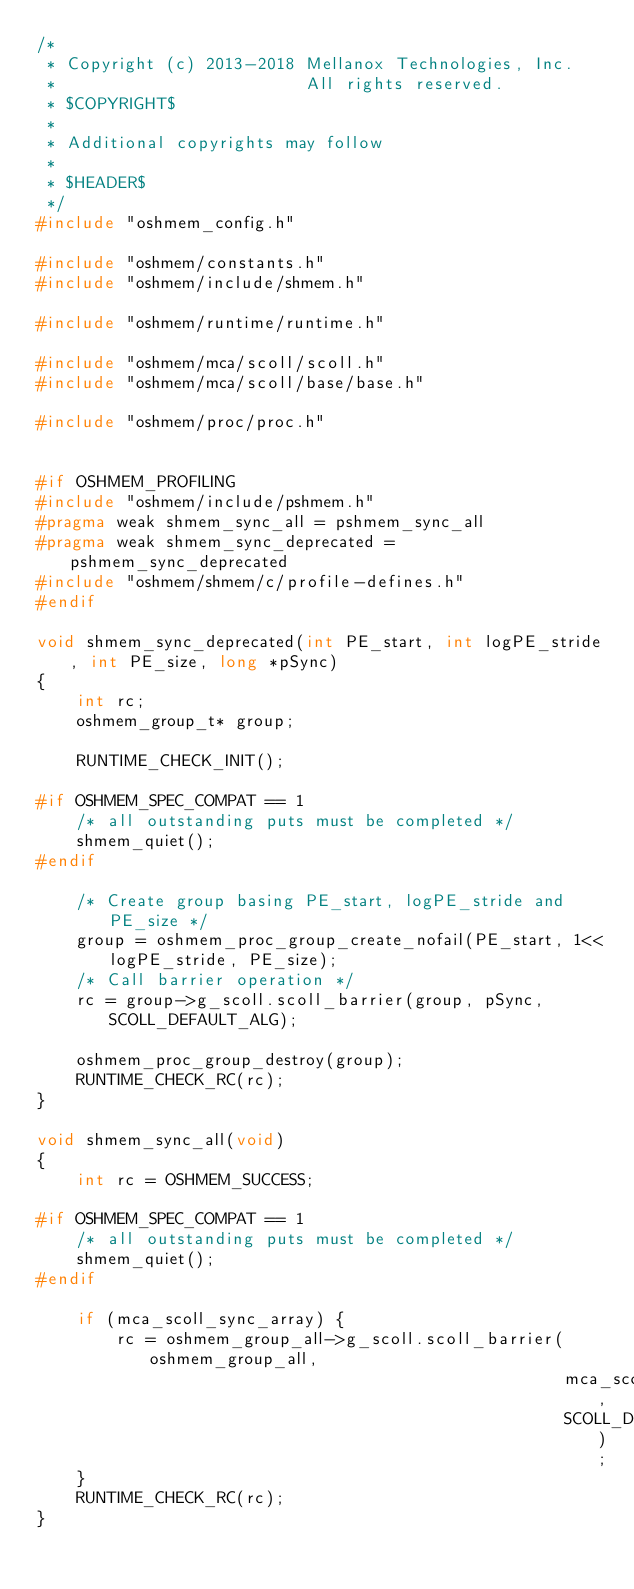Convert code to text. <code><loc_0><loc_0><loc_500><loc_500><_C_>/*
 * Copyright (c) 2013-2018 Mellanox Technologies, Inc.
 *                         All rights reserved.
 * $COPYRIGHT$
 *
 * Additional copyrights may follow
 *
 * $HEADER$
 */
#include "oshmem_config.h"

#include "oshmem/constants.h"
#include "oshmem/include/shmem.h"

#include "oshmem/runtime/runtime.h"

#include "oshmem/mca/scoll/scoll.h"
#include "oshmem/mca/scoll/base/base.h"

#include "oshmem/proc/proc.h"


#if OSHMEM_PROFILING
#include "oshmem/include/pshmem.h"
#pragma weak shmem_sync_all = pshmem_sync_all
#pragma weak shmem_sync_deprecated = pshmem_sync_deprecated
#include "oshmem/shmem/c/profile-defines.h"
#endif

void shmem_sync_deprecated(int PE_start, int logPE_stride, int PE_size, long *pSync)
{
    int rc;
    oshmem_group_t* group;

    RUNTIME_CHECK_INIT();

#if OSHMEM_SPEC_COMPAT == 1
    /* all outstanding puts must be completed */
    shmem_quiet();
#endif

    /* Create group basing PE_start, logPE_stride and PE_size */
    group = oshmem_proc_group_create_nofail(PE_start, 1<<logPE_stride, PE_size);
    /* Call barrier operation */
    rc = group->g_scoll.scoll_barrier(group, pSync, SCOLL_DEFAULT_ALG);

    oshmem_proc_group_destroy(group);
    RUNTIME_CHECK_RC(rc);
}

void shmem_sync_all(void)
{
    int rc = OSHMEM_SUCCESS;

#if OSHMEM_SPEC_COMPAT == 1
    /* all outstanding puts must be completed */
    shmem_quiet();
#endif

    if (mca_scoll_sync_array) {
        rc = oshmem_group_all->g_scoll.scoll_barrier(oshmem_group_all,
                                                     mca_scoll_sync_array,
                                                     SCOLL_DEFAULT_ALG);
    }
    RUNTIME_CHECK_RC(rc);
}
</code> 